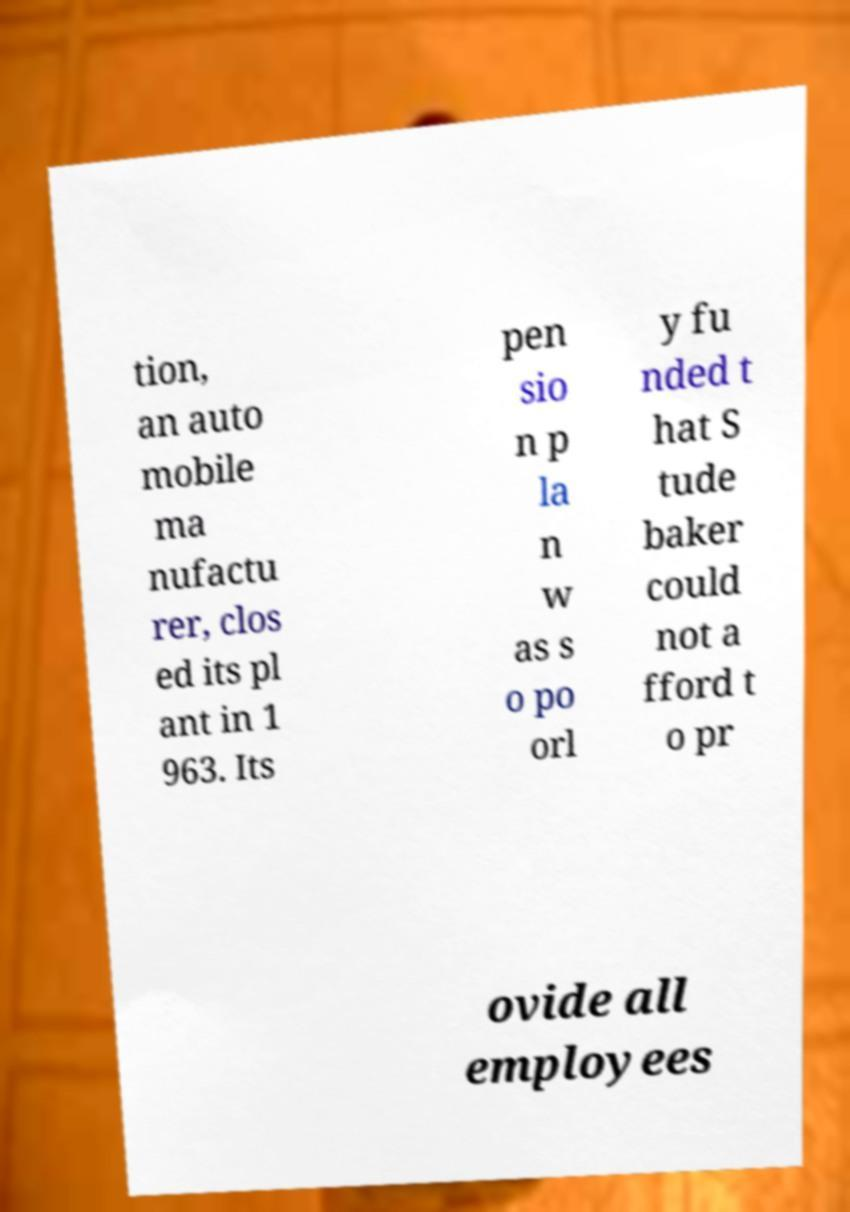Can you read and provide the text displayed in the image?This photo seems to have some interesting text. Can you extract and type it out for me? tion, an auto mobile ma nufactu rer, clos ed its pl ant in 1 963. Its pen sio n p la n w as s o po orl y fu nded t hat S tude baker could not a fford t o pr ovide all employees 